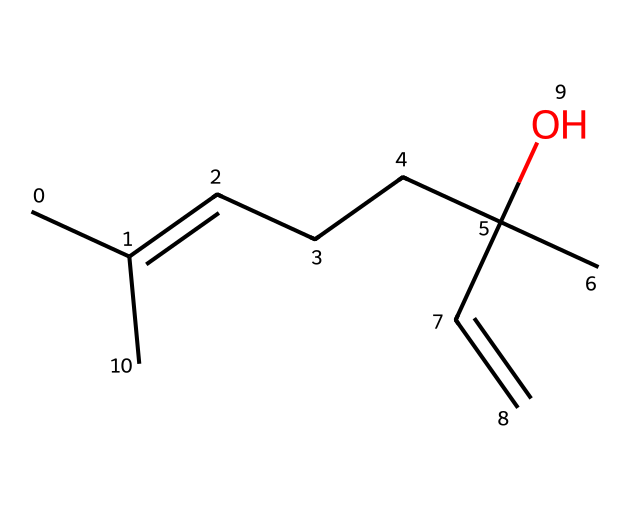What is the molecular formula of linalool? To find the molecular formula, count the number of each type of atom in the structure. In this case, there are 10 carbon atoms, 18 hydrogen atoms, and 1 oxygen atom. Therefore, the molecular formula is C10H18O.
Answer: C10H18O How many rings are present in linalool? By examining the structure provided, there are no closed loops or cyclic structures present. Thus, the number of rings is zero.
Answer: zero What functional group is present in linalool? The structure has a hydroxyl (-OH) functional group, as indicated by the oxygen connected to the carbon chain, making it an alcohol.
Answer: alcohol How many double bonds are in the chemical structure of linalool? To determine the number of double bonds, look for any carbon atoms connected by double lines in the structure. There is one double bond present (between two carbon atoms).
Answer: one What is the main characteristic smell of linalool? Linalool is primarily known for its floral scent, commonly associated with lavender and other aromatic plants.
Answer: floral Why might linalool be used in perfumes? The presence of the floral scent indicates that linalool is likely to provide a pleasant aroma or fragrance, making it a desirable component in perfumes and scented products.
Answer: pleasant aroma Is linalool a natural or synthetic compound? Linalool is predominantly found in many essential oils of plants, including lavender, indicating it is a natural compound produced by these plants.
Answer: natural 